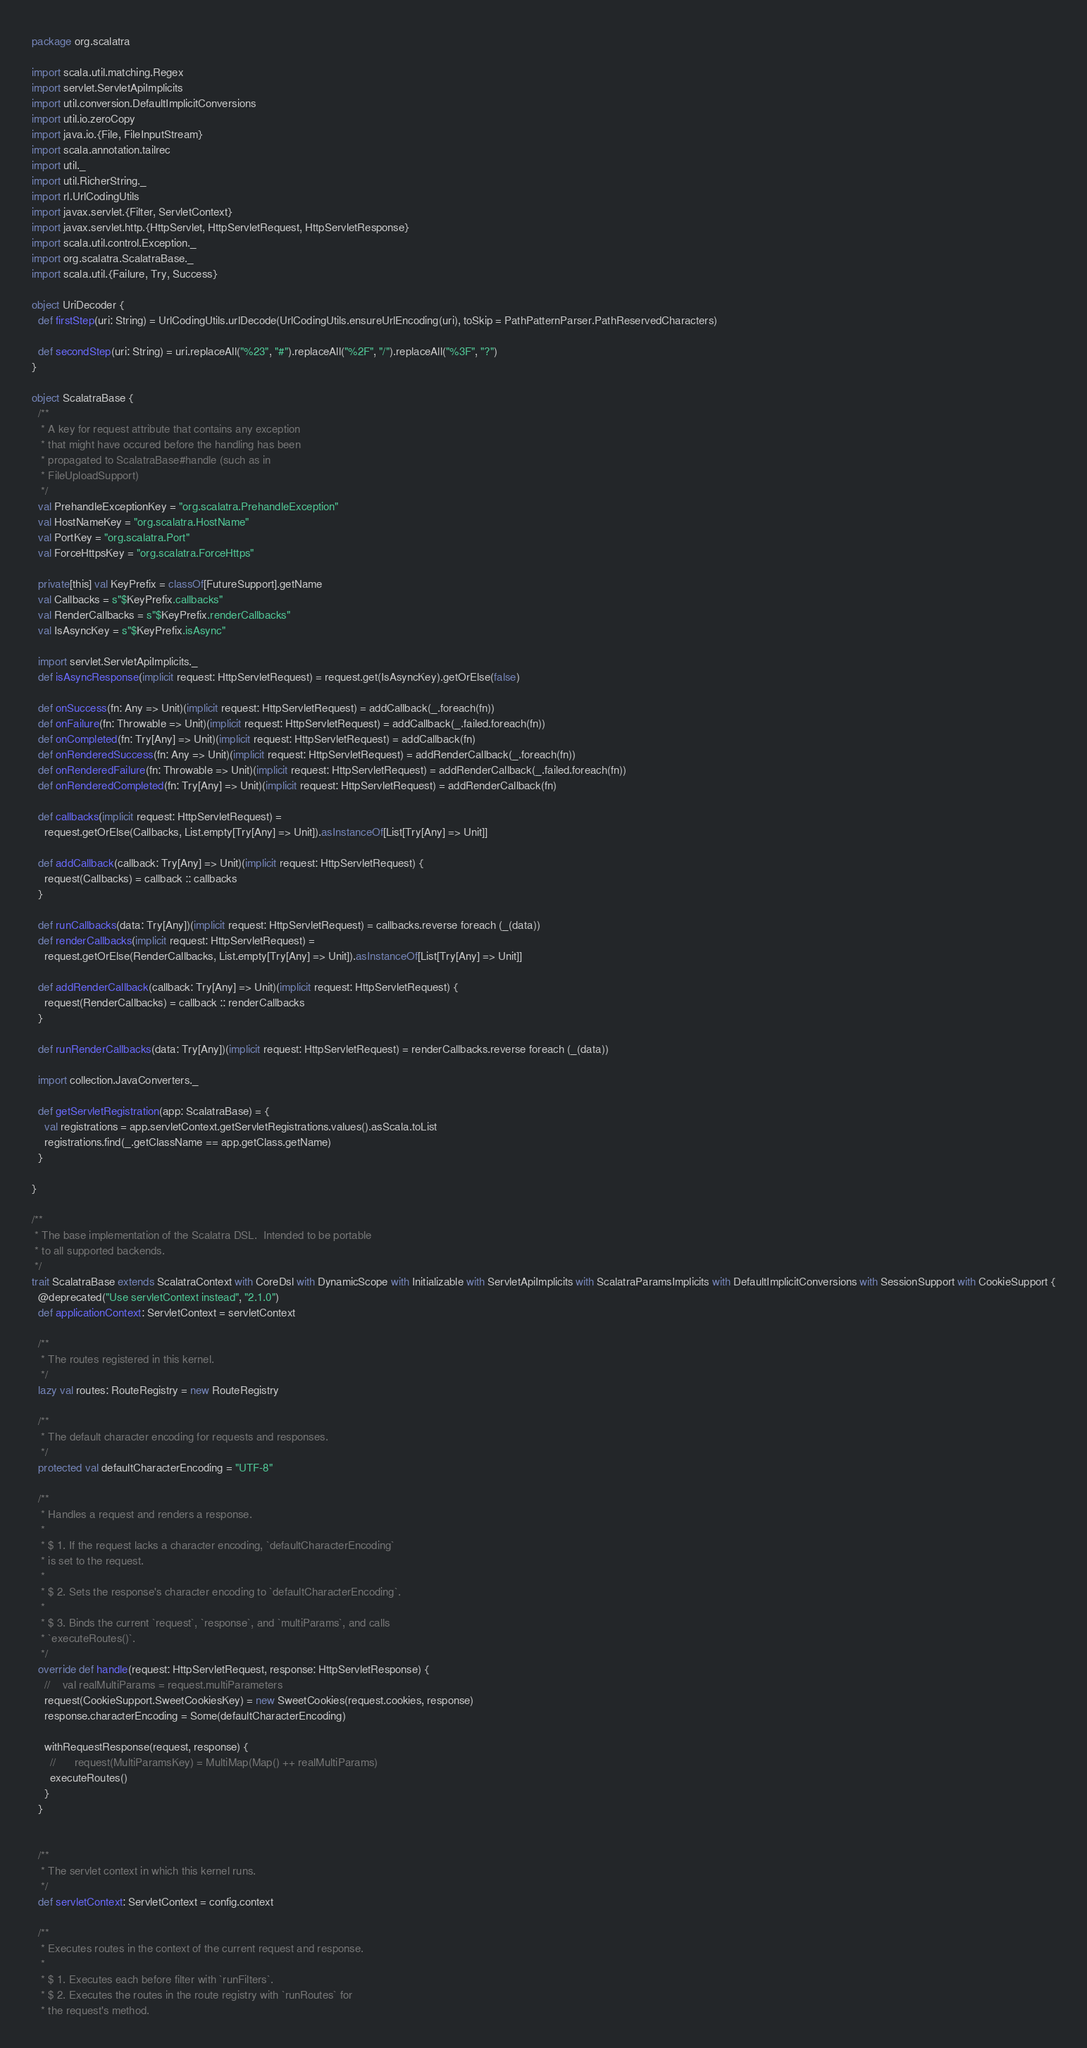Convert code to text. <code><loc_0><loc_0><loc_500><loc_500><_Scala_>package org.scalatra

import scala.util.matching.Regex
import servlet.ServletApiImplicits
import util.conversion.DefaultImplicitConversions
import util.io.zeroCopy
import java.io.{File, FileInputStream}
import scala.annotation.tailrec
import util._
import util.RicherString._
import rl.UrlCodingUtils
import javax.servlet.{Filter, ServletContext}
import javax.servlet.http.{HttpServlet, HttpServletRequest, HttpServletResponse}
import scala.util.control.Exception._
import org.scalatra.ScalatraBase._
import scala.util.{Failure, Try, Success}

object UriDecoder {
  def firstStep(uri: String) = UrlCodingUtils.urlDecode(UrlCodingUtils.ensureUrlEncoding(uri), toSkip = PathPatternParser.PathReservedCharacters)

  def secondStep(uri: String) = uri.replaceAll("%23", "#").replaceAll("%2F", "/").replaceAll("%3F", "?")
}

object ScalatraBase {
  /**
   * A key for request attribute that contains any exception
   * that might have occured before the handling has been
   * propagated to ScalatraBase#handle (such as in
   * FileUploadSupport)
   */
  val PrehandleExceptionKey = "org.scalatra.PrehandleException"
  val HostNameKey = "org.scalatra.HostName"
  val PortKey = "org.scalatra.Port"
  val ForceHttpsKey = "org.scalatra.ForceHttps"

  private[this] val KeyPrefix = classOf[FutureSupport].getName
  val Callbacks = s"$KeyPrefix.callbacks"
  val RenderCallbacks = s"$KeyPrefix.renderCallbacks"
  val IsAsyncKey = s"$KeyPrefix.isAsync"

  import servlet.ServletApiImplicits._
  def isAsyncResponse(implicit request: HttpServletRequest) = request.get(IsAsyncKey).getOrElse(false)

  def onSuccess(fn: Any => Unit)(implicit request: HttpServletRequest) = addCallback(_.foreach(fn))
  def onFailure(fn: Throwable => Unit)(implicit request: HttpServletRequest) = addCallback(_.failed.foreach(fn))
  def onCompleted(fn: Try[Any] => Unit)(implicit request: HttpServletRequest) = addCallback(fn)
  def onRenderedSuccess(fn: Any => Unit)(implicit request: HttpServletRequest) = addRenderCallback(_.foreach(fn))
  def onRenderedFailure(fn: Throwable => Unit)(implicit request: HttpServletRequest) = addRenderCallback(_.failed.foreach(fn))
  def onRenderedCompleted(fn: Try[Any] => Unit)(implicit request: HttpServletRequest) = addRenderCallback(fn)

  def callbacks(implicit request: HttpServletRequest) =
    request.getOrElse(Callbacks, List.empty[Try[Any] => Unit]).asInstanceOf[List[Try[Any] => Unit]]

  def addCallback(callback: Try[Any] => Unit)(implicit request: HttpServletRequest) {
    request(Callbacks) = callback :: callbacks
  }

  def runCallbacks(data: Try[Any])(implicit request: HttpServletRequest) = callbacks.reverse foreach (_(data))
  def renderCallbacks(implicit request: HttpServletRequest) =
    request.getOrElse(RenderCallbacks, List.empty[Try[Any] => Unit]).asInstanceOf[List[Try[Any] => Unit]]

  def addRenderCallback(callback: Try[Any] => Unit)(implicit request: HttpServletRequest) {
    request(RenderCallbacks) = callback :: renderCallbacks
  }

  def runRenderCallbacks(data: Try[Any])(implicit request: HttpServletRequest) = renderCallbacks.reverse foreach (_(data))

  import collection.JavaConverters._

  def getServletRegistration(app: ScalatraBase) = {
    val registrations = app.servletContext.getServletRegistrations.values().asScala.toList
    registrations.find(_.getClassName == app.getClass.getName)
  }

}

/**
 * The base implementation of the Scalatra DSL.  Intended to be portable
 * to all supported backends.
 */
trait ScalatraBase extends ScalatraContext with CoreDsl with DynamicScope with Initializable with ServletApiImplicits with ScalatraParamsImplicits with DefaultImplicitConversions with SessionSupport with CookieSupport {
  @deprecated("Use servletContext instead", "2.1.0")
  def applicationContext: ServletContext = servletContext

  /**
   * The routes registered in this kernel.
   */
  lazy val routes: RouteRegistry = new RouteRegistry

  /**
   * The default character encoding for requests and responses.
   */
  protected val defaultCharacterEncoding = "UTF-8"

  /**
   * Handles a request and renders a response.
   *
   * $ 1. If the request lacks a character encoding, `defaultCharacterEncoding`
   * is set to the request.
   *
   * $ 2. Sets the response's character encoding to `defaultCharacterEncoding`.
   *
   * $ 3. Binds the current `request`, `response`, and `multiParams`, and calls
   * `executeRoutes()`.
   */
  override def handle(request: HttpServletRequest, response: HttpServletResponse) {
    //    val realMultiParams = request.multiParameters
    request(CookieSupport.SweetCookiesKey) = new SweetCookies(request.cookies, response)
    response.characterEncoding = Some(defaultCharacterEncoding)

    withRequestResponse(request, response) {
      //      request(MultiParamsKey) = MultiMap(Map() ++ realMultiParams)
      executeRoutes()
    }
  }


  /**
   * The servlet context in which this kernel runs.
   */
  def servletContext: ServletContext = config.context

  /**
   * Executes routes in the context of the current request and response.
   *
   * $ 1. Executes each before filter with `runFilters`.
   * $ 2. Executes the routes in the route registry with `runRoutes` for
   * the request's method.</code> 